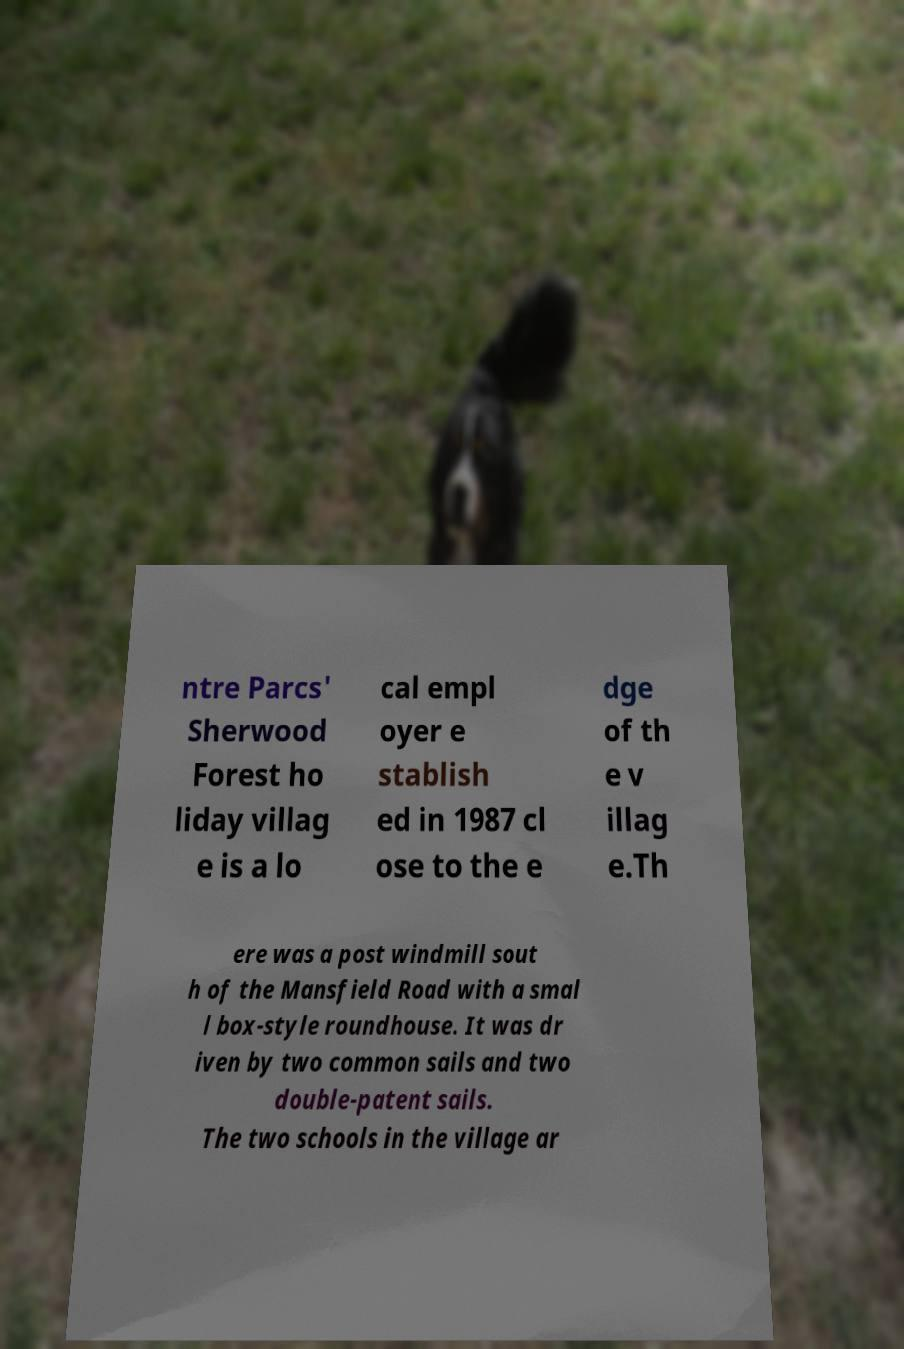For documentation purposes, I need the text within this image transcribed. Could you provide that? ntre Parcs' Sherwood Forest ho liday villag e is a lo cal empl oyer e stablish ed in 1987 cl ose to the e dge of th e v illag e.Th ere was a post windmill sout h of the Mansfield Road with a smal l box-style roundhouse. It was dr iven by two common sails and two double-patent sails. The two schools in the village ar 